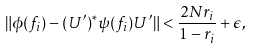Convert formula to latex. <formula><loc_0><loc_0><loc_500><loc_500>\| \phi ( f _ { i } ) - ( U ^ { \prime } ) ^ { * } \psi ( f _ { i } ) U ^ { \prime } \| < \frac { 2 N r _ { i } } { 1 - r _ { i } } + \epsilon ,</formula> 